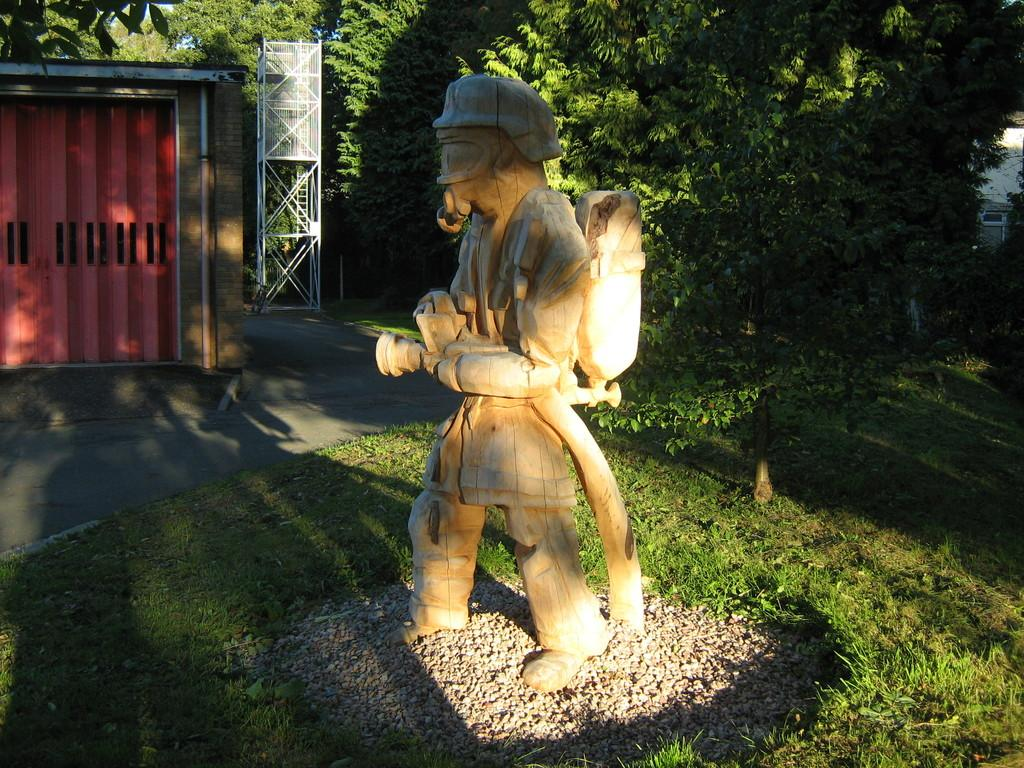What is the main subject in the image? There is a statue in the image. What type of ground surface is visible in the image? There are stones and grass in the image. What type of structure is present in the image? There is a shed in the image. What object might be used for climbing in the image? There is a ladder in the image. What object might be used for displaying or holding something in the image? There is a stand in the image. What can be seen in the background of the image? There are trees in the background of the image. Can you tell me how the pet is interacting with the statue in the image? There is no pet present in the image, so it cannot be determined how a pet might interact with the statue. 